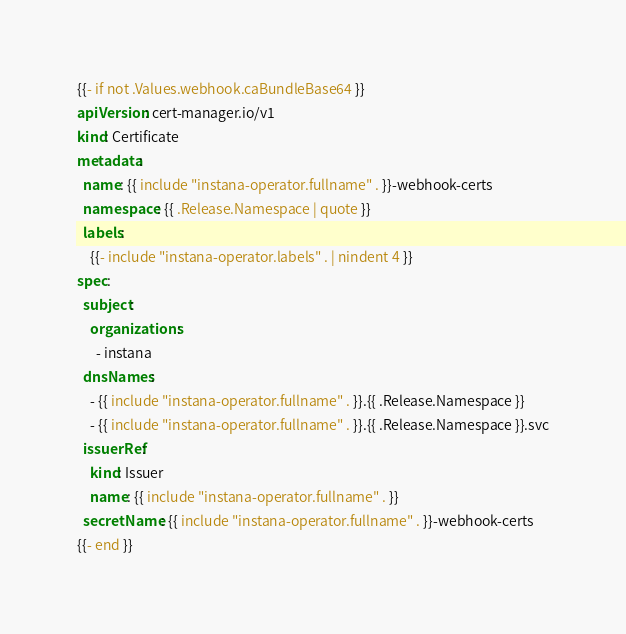<code> <loc_0><loc_0><loc_500><loc_500><_YAML_>{{- if not .Values.webhook.caBundleBase64 }}
apiVersion: cert-manager.io/v1
kind: Certificate
metadata:
  name: {{ include "instana-operator.fullname" . }}-webhook-certs
  namespace: {{ .Release.Namespace | quote }}
  labels:
    {{- include "instana-operator.labels" . | nindent 4 }}
spec:
  subject:
    organizations:
      - instana
  dnsNames:
    - {{ include "instana-operator.fullname" . }}.{{ .Release.Namespace }}
    - {{ include "instana-operator.fullname" . }}.{{ .Release.Namespace }}.svc
  issuerRef:
    kind: Issuer
    name: {{ include "instana-operator.fullname" . }}
  secretName: {{ include "instana-operator.fullname" . }}-webhook-certs
{{- end }}
</code> 